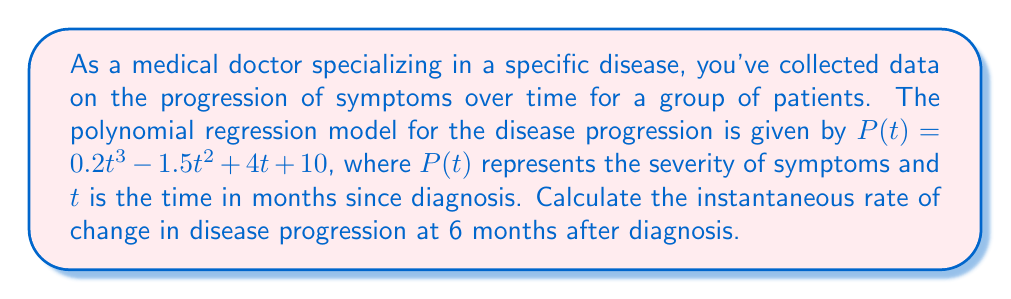Provide a solution to this math problem. To find the instantaneous rate of change in disease progression at 6 months, we need to follow these steps:

1. The rate of change is given by the derivative of the polynomial function $P(t)$.

2. Let's find the derivative $P'(t)$:
   $$P'(t) = \frac{d}{dt}(0.2t^3 - 1.5t^2 + 4t + 10)$$
   $$P'(t) = 0.6t^2 - 3t + 4$$

3. Now, we need to evaluate $P'(t)$ at $t = 6$:
   $$P'(6) = 0.6(6)^2 - 3(6) + 4$$
   $$P'(6) = 0.6(36) - 18 + 4$$
   $$P'(6) = 21.6 - 18 + 4$$
   $$P'(6) = 7.6$$

4. The instantaneous rate of change at 6 months is 7.6 units of severity per month.
Answer: 7.6 units/month 